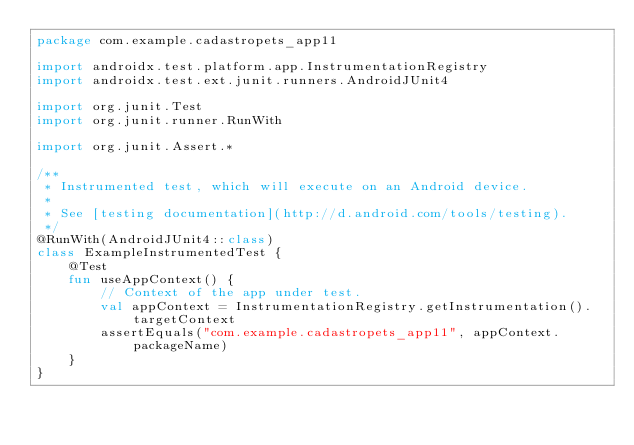<code> <loc_0><loc_0><loc_500><loc_500><_Kotlin_>package com.example.cadastropets_app11

import androidx.test.platform.app.InstrumentationRegistry
import androidx.test.ext.junit.runners.AndroidJUnit4

import org.junit.Test
import org.junit.runner.RunWith

import org.junit.Assert.*

/**
 * Instrumented test, which will execute on an Android device.
 *
 * See [testing documentation](http://d.android.com/tools/testing).
 */
@RunWith(AndroidJUnit4::class)
class ExampleInstrumentedTest {
    @Test
    fun useAppContext() {
        // Context of the app under test.
        val appContext = InstrumentationRegistry.getInstrumentation().targetContext
        assertEquals("com.example.cadastropets_app11", appContext.packageName)
    }
}</code> 